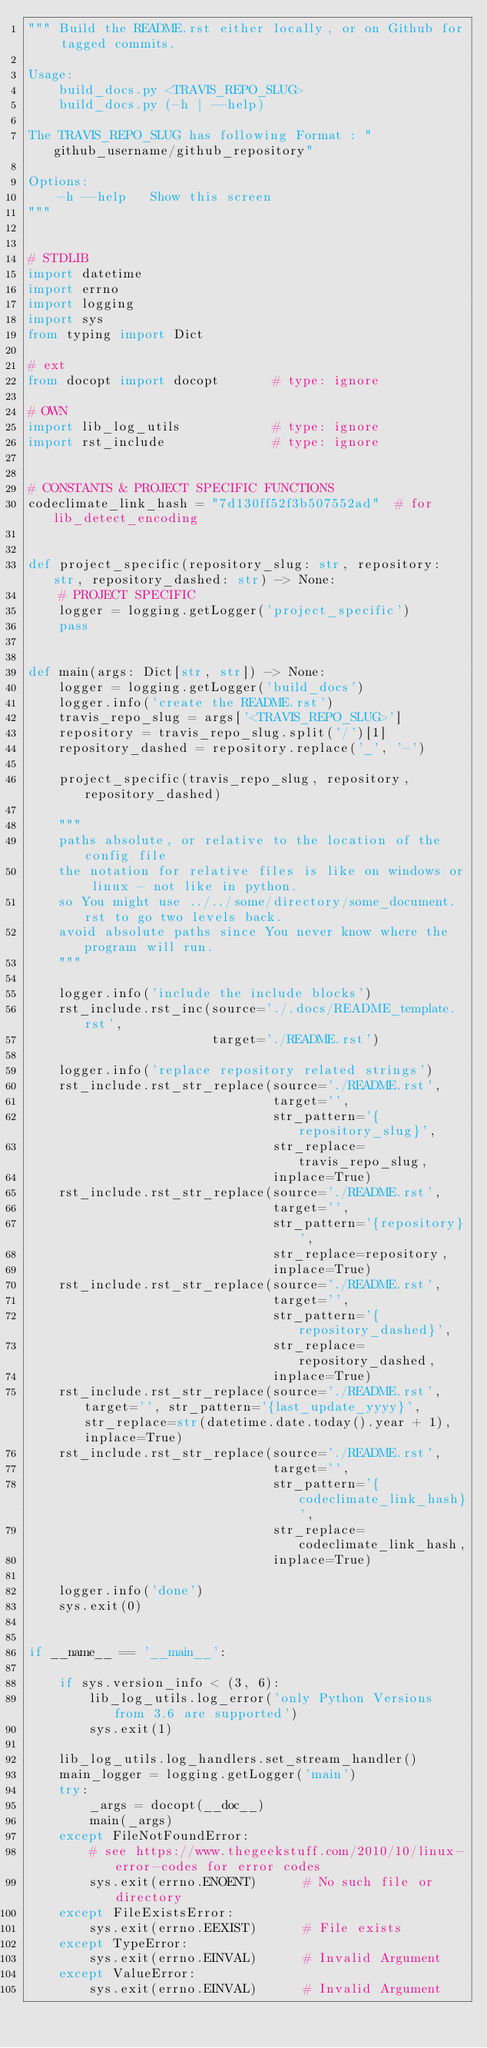<code> <loc_0><loc_0><loc_500><loc_500><_Python_>""" Build the README.rst either locally, or on Github for tagged commits.

Usage:
    build_docs.py <TRAVIS_REPO_SLUG>
    build_docs.py (-h | --help)

The TRAVIS_REPO_SLUG has following Format : "github_username/github_repository"

Options:
    -h --help   Show this screen
"""


# STDLIB
import datetime
import errno
import logging
import sys
from typing import Dict

# ext
from docopt import docopt       # type: ignore

# OWN
import lib_log_utils            # type: ignore
import rst_include              # type: ignore


# CONSTANTS & PROJECT SPECIFIC FUNCTIONS
codeclimate_link_hash = "7d130ff52f3b507552ad"  # for lib_detect_encoding


def project_specific(repository_slug: str, repository: str, repository_dashed: str) -> None:
    # PROJECT SPECIFIC
    logger = logging.getLogger('project_specific')
    pass


def main(args: Dict[str, str]) -> None:
    logger = logging.getLogger('build_docs')
    logger.info('create the README.rst')
    travis_repo_slug = args['<TRAVIS_REPO_SLUG>']
    repository = travis_repo_slug.split('/')[1]
    repository_dashed = repository.replace('_', '-')

    project_specific(travis_repo_slug, repository, repository_dashed)

    """
    paths absolute, or relative to the location of the config file
    the notation for relative files is like on windows or linux - not like in python.
    so You might use ../../some/directory/some_document.rst to go two levels back.
    avoid absolute paths since You never know where the program will run.
    """

    logger.info('include the include blocks')
    rst_include.rst_inc(source='./.docs/README_template.rst',
                        target='./README.rst')

    logger.info('replace repository related strings')
    rst_include.rst_str_replace(source='./README.rst',
                                target='',
                                str_pattern='{repository_slug}',
                                str_replace=travis_repo_slug,
                                inplace=True)
    rst_include.rst_str_replace(source='./README.rst',
                                target='',
                                str_pattern='{repository}',
                                str_replace=repository,
                                inplace=True)
    rst_include.rst_str_replace(source='./README.rst',
                                target='',
                                str_pattern='{repository_dashed}',
                                str_replace=repository_dashed,
                                inplace=True)
    rst_include.rst_str_replace(source='./README.rst', target='', str_pattern='{last_update_yyyy}', str_replace=str(datetime.date.today().year + 1), inplace=True)
    rst_include.rst_str_replace(source='./README.rst',
                                target='',
                                str_pattern='{codeclimate_link_hash}',
                                str_replace=codeclimate_link_hash,
                                inplace=True)

    logger.info('done')
    sys.exit(0)


if __name__ == '__main__':

    if sys.version_info < (3, 6):
        lib_log_utils.log_error('only Python Versions from 3.6 are supported')
        sys.exit(1)

    lib_log_utils.log_handlers.set_stream_handler()
    main_logger = logging.getLogger('main')
    try:
        _args = docopt(__doc__)
        main(_args)
    except FileNotFoundError:
        # see https://www.thegeekstuff.com/2010/10/linux-error-codes for error codes
        sys.exit(errno.ENOENT)      # No such file or directory
    except FileExistsError:
        sys.exit(errno.EEXIST)      # File exists
    except TypeError:
        sys.exit(errno.EINVAL)      # Invalid Argument
    except ValueError:
        sys.exit(errno.EINVAL)      # Invalid Argument
</code> 